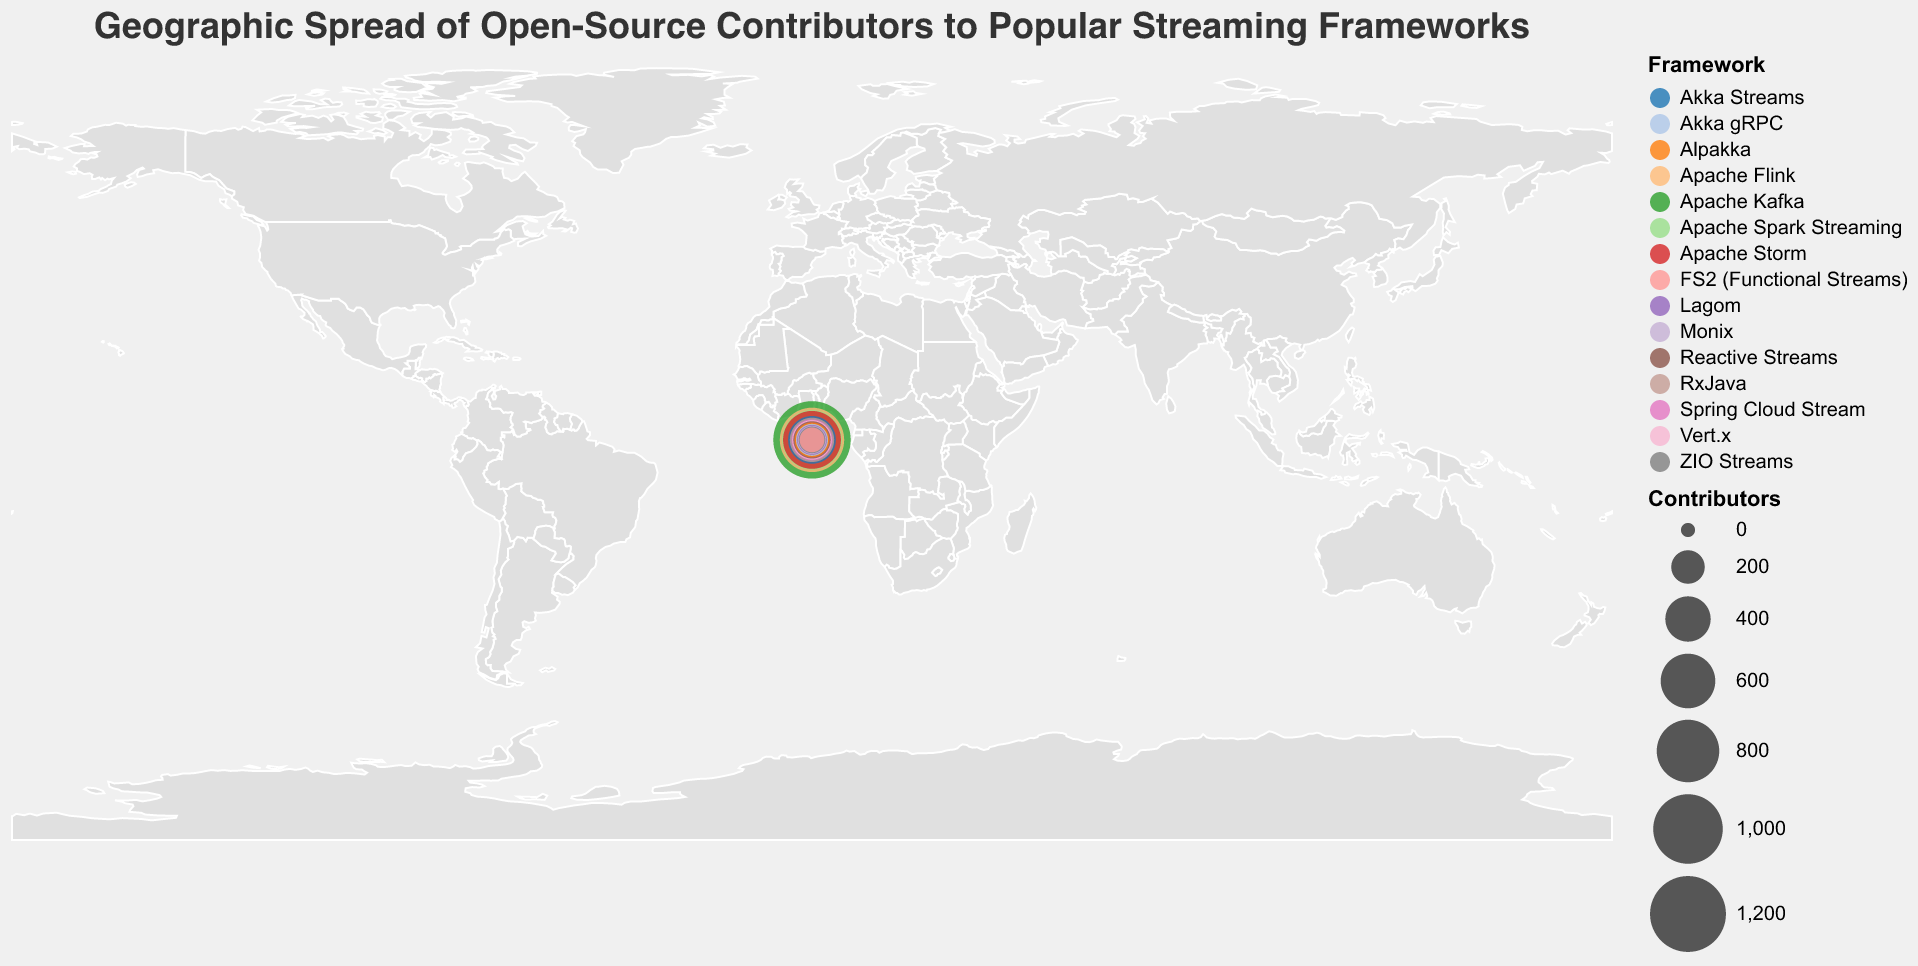Which country has the most contributors to a single framework? The circle representing the USA is the largest on the map. According to the tooltip, it shows that the USA has 1250 contributors to Apache Kafka.
Answer: USA How many contributors are there in total from Germany and France? Germany has 850 contributors for Apache Flink, and France has 290 contributors for Vert.x. Adding them together, we get 850 + 290 = 1140.
Answer: 1140 Which framework has the least number of contributors? The smallest circle on the map represents Poland with FS2 (Functional Streams) having only 90 contributors.
Answer: FS2 (Functional Streams) Which two countries have closer numbers of contributors, Sweden or Brazil? Sweden has 110 contributors for ZIO Streams, and Brazil has 180 contributors for Akka gRPC. The difference between them is 180 - 110 = 70.
Answer: Sweden and Brazil How many frameworks have a greater number of contributors than Alpakka in Australia? Alpakka in Australia has 220 contributors. The countries with more than 220 contributors are USA (1250), Germany (850), China (720), India (680), UK (450), Netherlands (380), and Canada (320). This sums up to 7 frameworks.
Answer: 7 Which continent has the highest total contributors by summing up North America, Europe, and Asia? North America (USA + Canada) = 1250 + 320 = 1570,
Europe (Germany + UK + Netherlands + France + Russia + Spain + Sweden + Poland) = 850 + 450 + 380 + 290 + 150 + 130 + 110 + 90 = 2450,
Asia (China + India + Japan) = 720 + 680 + 260 = 1660.
Europe has the highest total contributors.
Answer: Europe What is the average number of contributors across all countries? Summing contributors from all countries: 1250 + 850 + 720 + 680 + 450 + 380 + 320 + 290 + 260 + 220 + 180 + 150 + 130 + 110 + 90 = 6080. 
There are 15 countries, so the average is 6080 / 15 = 405.33 (approximately).
Answer: 405.33 